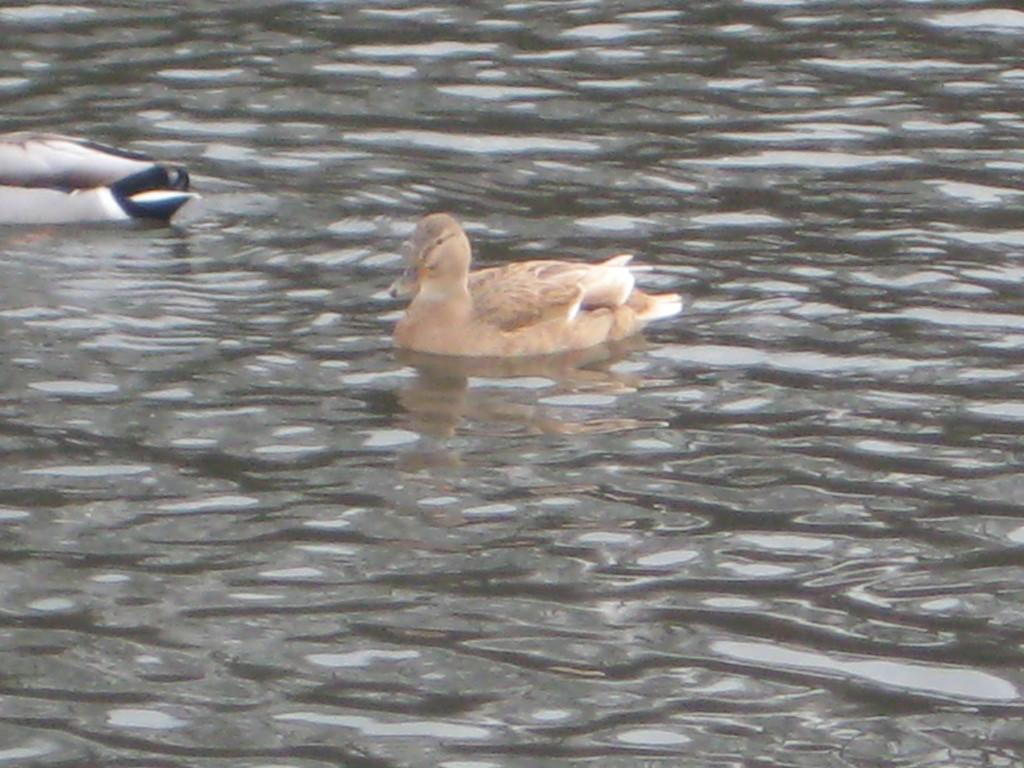What type of animals can be seen in the image? There are birds in the image. What are the birds doing in the image? The birds are swimming in the water. What type of brick is being used by the birds to build their nest in the image? There is no brick present in the image, as the birds are swimming in the water. Can you see any fangs on the birds in the image? Birds do not have fangs, so there are no fangs visible in the image. 